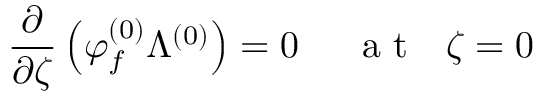<formula> <loc_0><loc_0><loc_500><loc_500>\frac { \partial } { \partial \zeta } \left ( \varphi _ { f } ^ { ( 0 ) } \Lambda ^ { ( 0 ) } \right ) = 0 a t \zeta = 0</formula> 